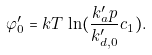Convert formula to latex. <formula><loc_0><loc_0><loc_500><loc_500>\varphi ^ { \prime } _ { 0 } = k T \, \ln ( \frac { k ^ { \prime } _ { a } p } { k ^ { \prime } _ { d , 0 } } c _ { 1 } ) .</formula> 